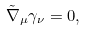<formula> <loc_0><loc_0><loc_500><loc_500>\tilde { \nabla } _ { \mu } \gamma _ { \nu } = 0 ,</formula> 